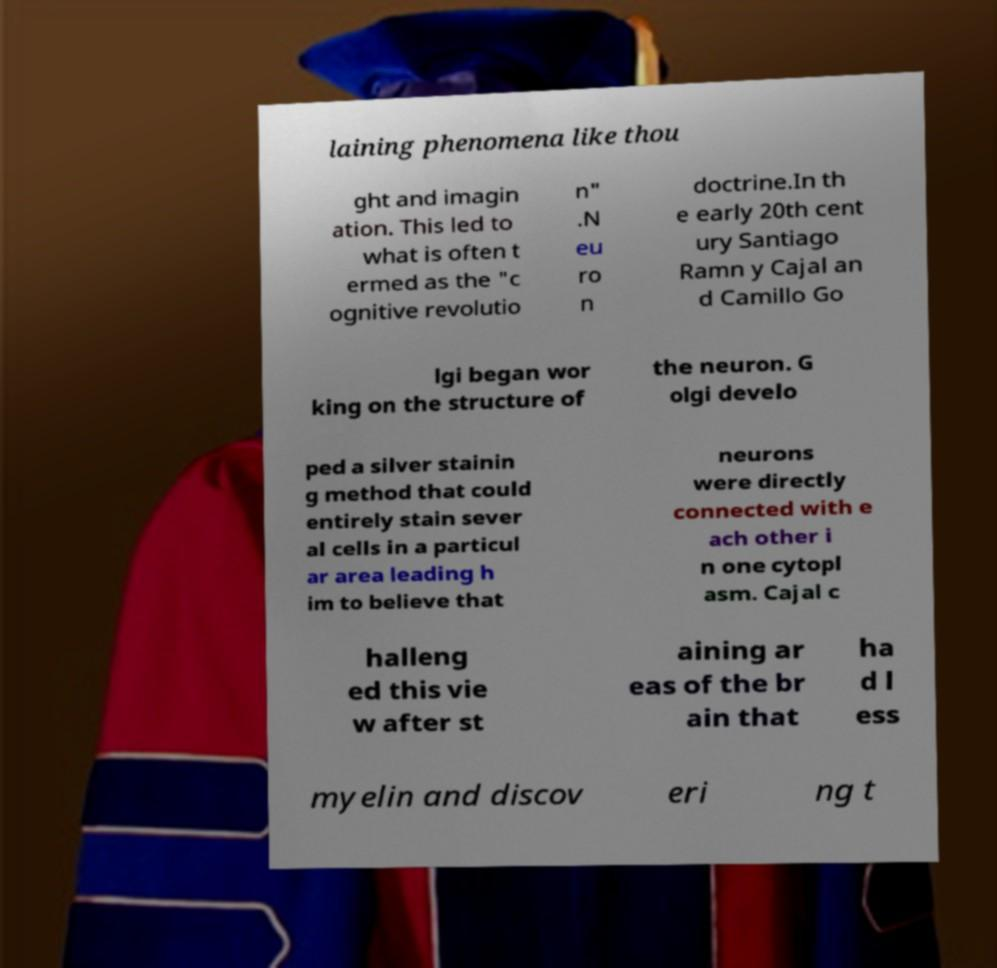Could you extract and type out the text from this image? laining phenomena like thou ght and imagin ation. This led to what is often t ermed as the "c ognitive revolutio n" .N eu ro n doctrine.In th e early 20th cent ury Santiago Ramn y Cajal an d Camillo Go lgi began wor king on the structure of the neuron. G olgi develo ped a silver stainin g method that could entirely stain sever al cells in a particul ar area leading h im to believe that neurons were directly connected with e ach other i n one cytopl asm. Cajal c halleng ed this vie w after st aining ar eas of the br ain that ha d l ess myelin and discov eri ng t 